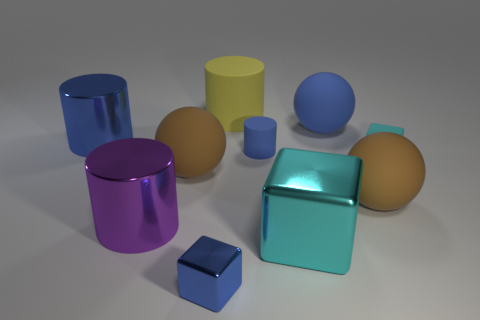What could be the possible usage of these objects in real life? These objects, with their cylindrical and cubical shapes, could serve various purposes, such as containers for storage, decorative vases, or even as educational models to demonstrate geometric shapes and properties. 